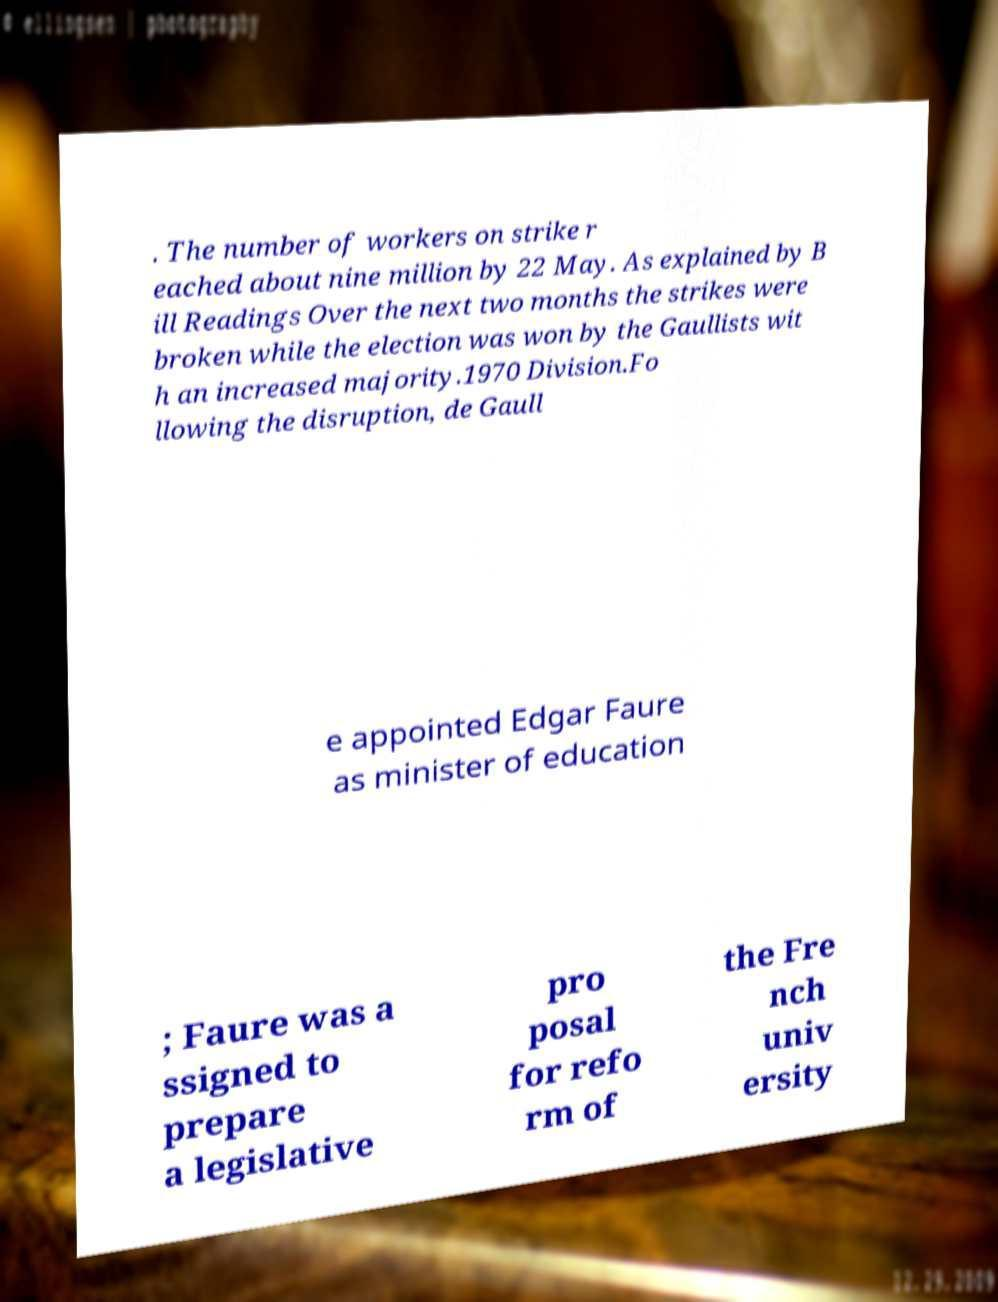Could you extract and type out the text from this image? . The number of workers on strike r eached about nine million by 22 May. As explained by B ill Readings Over the next two months the strikes were broken while the election was won by the Gaullists wit h an increased majority.1970 Division.Fo llowing the disruption, de Gaull e appointed Edgar Faure as minister of education ; Faure was a ssigned to prepare a legislative pro posal for refo rm of the Fre nch univ ersity 